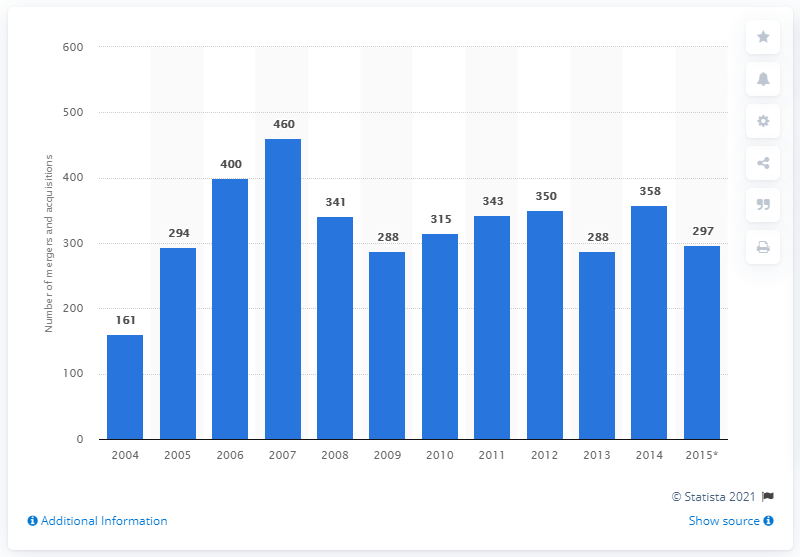Specify some key components in this picture. In 2004, there were 161 mergers and acquisitions (M&A) deals related to plastics and packaging. In 2007, there were 460 merger and acquisition deals in the plastics and packaging industry. 